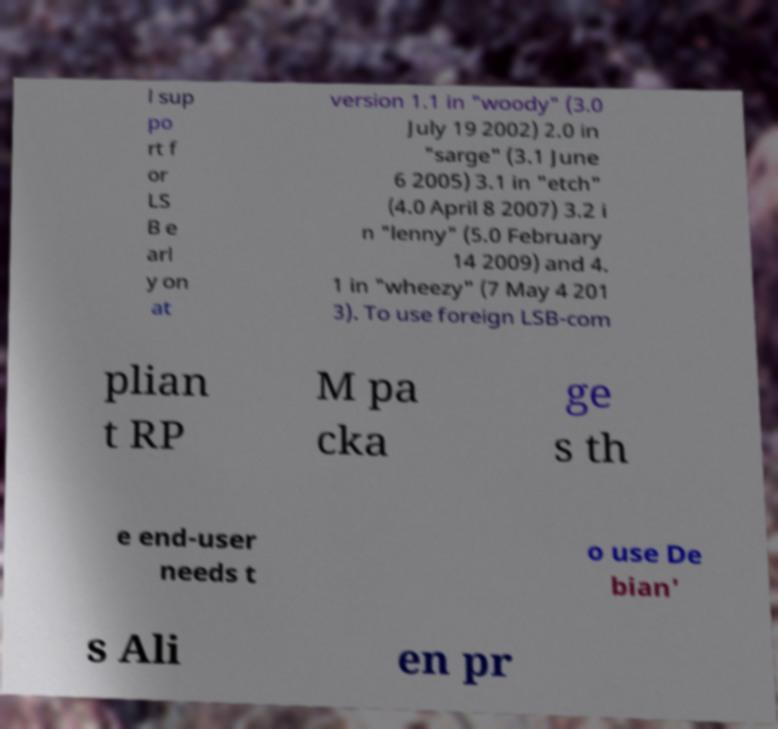Can you accurately transcribe the text from the provided image for me? l sup po rt f or LS B e arl y on at version 1.1 in "woody" (3.0 July 19 2002) 2.0 in "sarge" (3.1 June 6 2005) 3.1 in "etch" (4.0 April 8 2007) 3.2 i n "lenny" (5.0 February 14 2009) and 4. 1 in "wheezy" (7 May 4 201 3). To use foreign LSB-com plian t RP M pa cka ge s th e end-user needs t o use De bian' s Ali en pr 